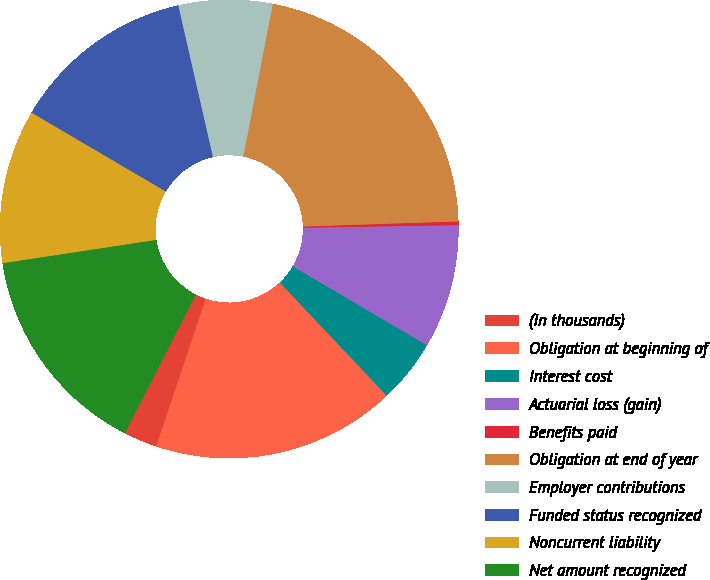Convert chart. <chart><loc_0><loc_0><loc_500><loc_500><pie_chart><fcel>(In thousands)<fcel>Obligation at beginning of<fcel>Interest cost<fcel>Actuarial loss (gain)<fcel>Benefits paid<fcel>Obligation at end of year<fcel>Employer contributions<fcel>Funded status recognized<fcel>Noncurrent liability<fcel>Net amount recognized<nl><fcel>2.37%<fcel>17.2%<fcel>4.49%<fcel>8.73%<fcel>0.26%<fcel>21.44%<fcel>6.61%<fcel>12.97%<fcel>10.85%<fcel>15.08%<nl></chart> 